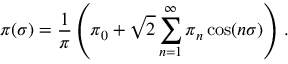Convert formula to latex. <formula><loc_0><loc_0><loc_500><loc_500>\pi ( \sigma ) = { \frac { 1 } { \pi } } \left ( \pi _ { 0 } + { \sqrt { 2 } } \sum _ { n = 1 } ^ { \infty } \pi _ { n } \cos ( n \sigma ) \right ) \, .</formula> 